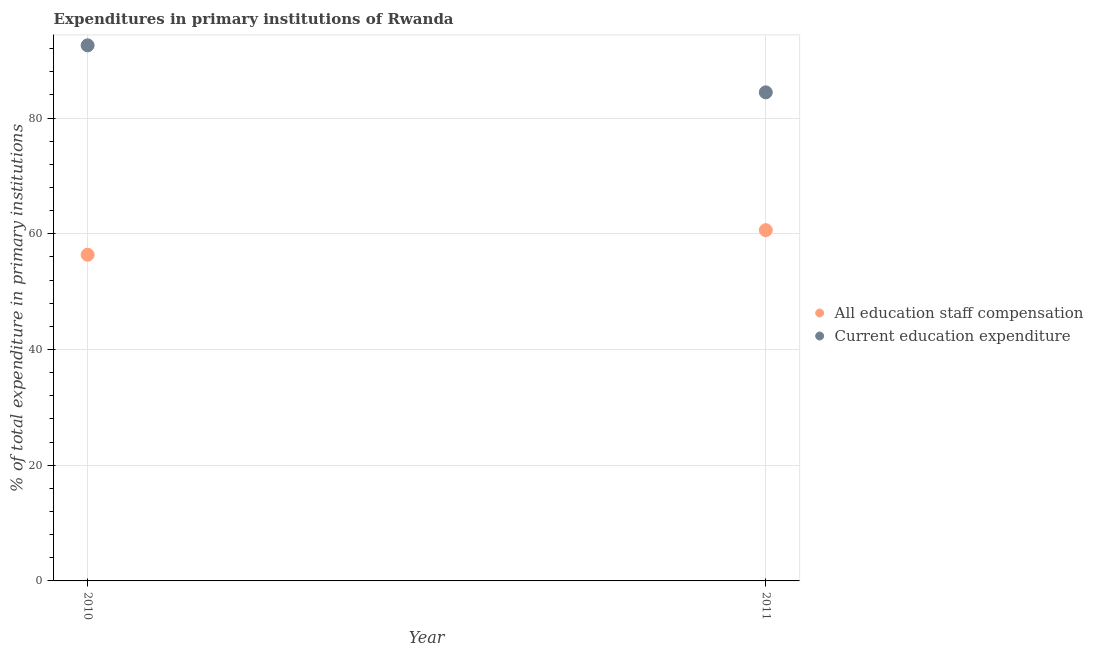How many different coloured dotlines are there?
Give a very brief answer. 2. What is the expenditure in education in 2011?
Make the answer very short. 84.46. Across all years, what is the maximum expenditure in education?
Make the answer very short. 92.58. Across all years, what is the minimum expenditure in staff compensation?
Offer a very short reply. 56.39. In which year was the expenditure in education minimum?
Your answer should be compact. 2011. What is the total expenditure in staff compensation in the graph?
Give a very brief answer. 117.02. What is the difference between the expenditure in education in 2010 and that in 2011?
Keep it short and to the point. 8.12. What is the difference between the expenditure in staff compensation in 2011 and the expenditure in education in 2010?
Give a very brief answer. -31.94. What is the average expenditure in education per year?
Provide a succinct answer. 88.52. In the year 2010, what is the difference between the expenditure in staff compensation and expenditure in education?
Your answer should be compact. -36.19. What is the ratio of the expenditure in education in 2010 to that in 2011?
Make the answer very short. 1.1. In how many years, is the expenditure in staff compensation greater than the average expenditure in staff compensation taken over all years?
Keep it short and to the point. 1. Does the expenditure in staff compensation monotonically increase over the years?
Your answer should be very brief. Yes. Is the expenditure in staff compensation strictly less than the expenditure in education over the years?
Make the answer very short. Yes. How many dotlines are there?
Give a very brief answer. 2. How many years are there in the graph?
Keep it short and to the point. 2. What is the difference between two consecutive major ticks on the Y-axis?
Give a very brief answer. 20. Does the graph contain any zero values?
Offer a terse response. No. How many legend labels are there?
Your answer should be compact. 2. How are the legend labels stacked?
Your response must be concise. Vertical. What is the title of the graph?
Offer a terse response. Expenditures in primary institutions of Rwanda. Does "By country of asylum" appear as one of the legend labels in the graph?
Offer a very short reply. No. What is the label or title of the Y-axis?
Your answer should be compact. % of total expenditure in primary institutions. What is the % of total expenditure in primary institutions in All education staff compensation in 2010?
Your answer should be very brief. 56.39. What is the % of total expenditure in primary institutions of Current education expenditure in 2010?
Ensure brevity in your answer.  92.58. What is the % of total expenditure in primary institutions of All education staff compensation in 2011?
Ensure brevity in your answer.  60.64. What is the % of total expenditure in primary institutions of Current education expenditure in 2011?
Your response must be concise. 84.46. Across all years, what is the maximum % of total expenditure in primary institutions in All education staff compensation?
Your response must be concise. 60.64. Across all years, what is the maximum % of total expenditure in primary institutions in Current education expenditure?
Ensure brevity in your answer.  92.58. Across all years, what is the minimum % of total expenditure in primary institutions in All education staff compensation?
Your answer should be compact. 56.39. Across all years, what is the minimum % of total expenditure in primary institutions in Current education expenditure?
Make the answer very short. 84.46. What is the total % of total expenditure in primary institutions in All education staff compensation in the graph?
Offer a terse response. 117.02. What is the total % of total expenditure in primary institutions of Current education expenditure in the graph?
Give a very brief answer. 177.03. What is the difference between the % of total expenditure in primary institutions of All education staff compensation in 2010 and that in 2011?
Keep it short and to the point. -4.25. What is the difference between the % of total expenditure in primary institutions in Current education expenditure in 2010 and that in 2011?
Offer a very short reply. 8.12. What is the difference between the % of total expenditure in primary institutions in All education staff compensation in 2010 and the % of total expenditure in primary institutions in Current education expenditure in 2011?
Ensure brevity in your answer.  -28.07. What is the average % of total expenditure in primary institutions of All education staff compensation per year?
Provide a succinct answer. 58.51. What is the average % of total expenditure in primary institutions of Current education expenditure per year?
Your response must be concise. 88.52. In the year 2010, what is the difference between the % of total expenditure in primary institutions of All education staff compensation and % of total expenditure in primary institutions of Current education expenditure?
Make the answer very short. -36.19. In the year 2011, what is the difference between the % of total expenditure in primary institutions in All education staff compensation and % of total expenditure in primary institutions in Current education expenditure?
Offer a terse response. -23.82. What is the ratio of the % of total expenditure in primary institutions in All education staff compensation in 2010 to that in 2011?
Offer a very short reply. 0.93. What is the ratio of the % of total expenditure in primary institutions of Current education expenditure in 2010 to that in 2011?
Your answer should be compact. 1.1. What is the difference between the highest and the second highest % of total expenditure in primary institutions in All education staff compensation?
Offer a terse response. 4.25. What is the difference between the highest and the second highest % of total expenditure in primary institutions of Current education expenditure?
Make the answer very short. 8.12. What is the difference between the highest and the lowest % of total expenditure in primary institutions in All education staff compensation?
Your answer should be very brief. 4.25. What is the difference between the highest and the lowest % of total expenditure in primary institutions of Current education expenditure?
Provide a succinct answer. 8.12. 